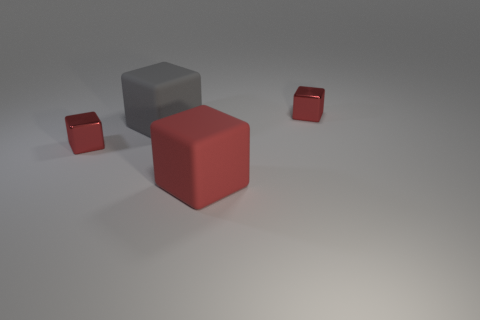Do the matte object behind the big red cube and the red matte thing have the same shape? yes 